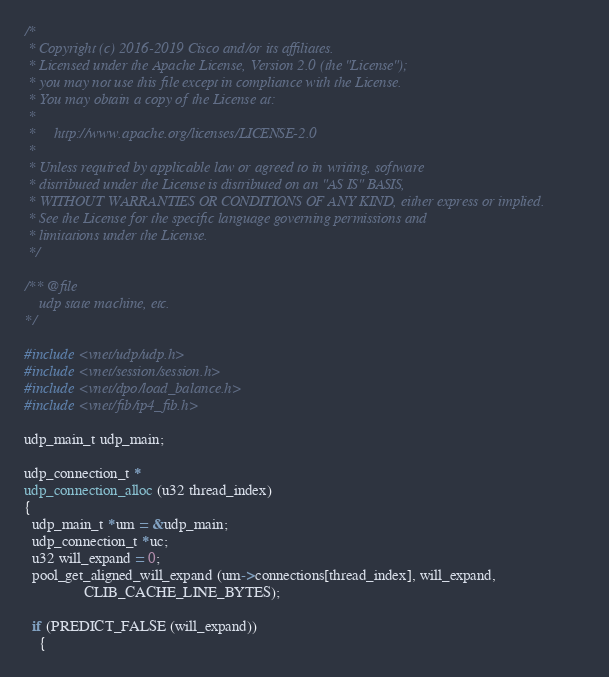<code> <loc_0><loc_0><loc_500><loc_500><_C_>/*
 * Copyright (c) 2016-2019 Cisco and/or its affiliates.
 * Licensed under the Apache License, Version 2.0 (the "License");
 * you may not use this file except in compliance with the License.
 * You may obtain a copy of the License at:
 *
 *     http://www.apache.org/licenses/LICENSE-2.0
 *
 * Unless required by applicable law or agreed to in writing, software
 * distributed under the License is distributed on an "AS IS" BASIS,
 * WITHOUT WARRANTIES OR CONDITIONS OF ANY KIND, either express or implied.
 * See the License for the specific language governing permissions and
 * limitations under the License.
 */

/** @file
    udp state machine, etc.
*/

#include <vnet/udp/udp.h>
#include <vnet/session/session.h>
#include <vnet/dpo/load_balance.h>
#include <vnet/fib/ip4_fib.h>

udp_main_t udp_main;

udp_connection_t *
udp_connection_alloc (u32 thread_index)
{
  udp_main_t *um = &udp_main;
  udp_connection_t *uc;
  u32 will_expand = 0;
  pool_get_aligned_will_expand (um->connections[thread_index], will_expand,
				CLIB_CACHE_LINE_BYTES);

  if (PREDICT_FALSE (will_expand))
    {</code> 